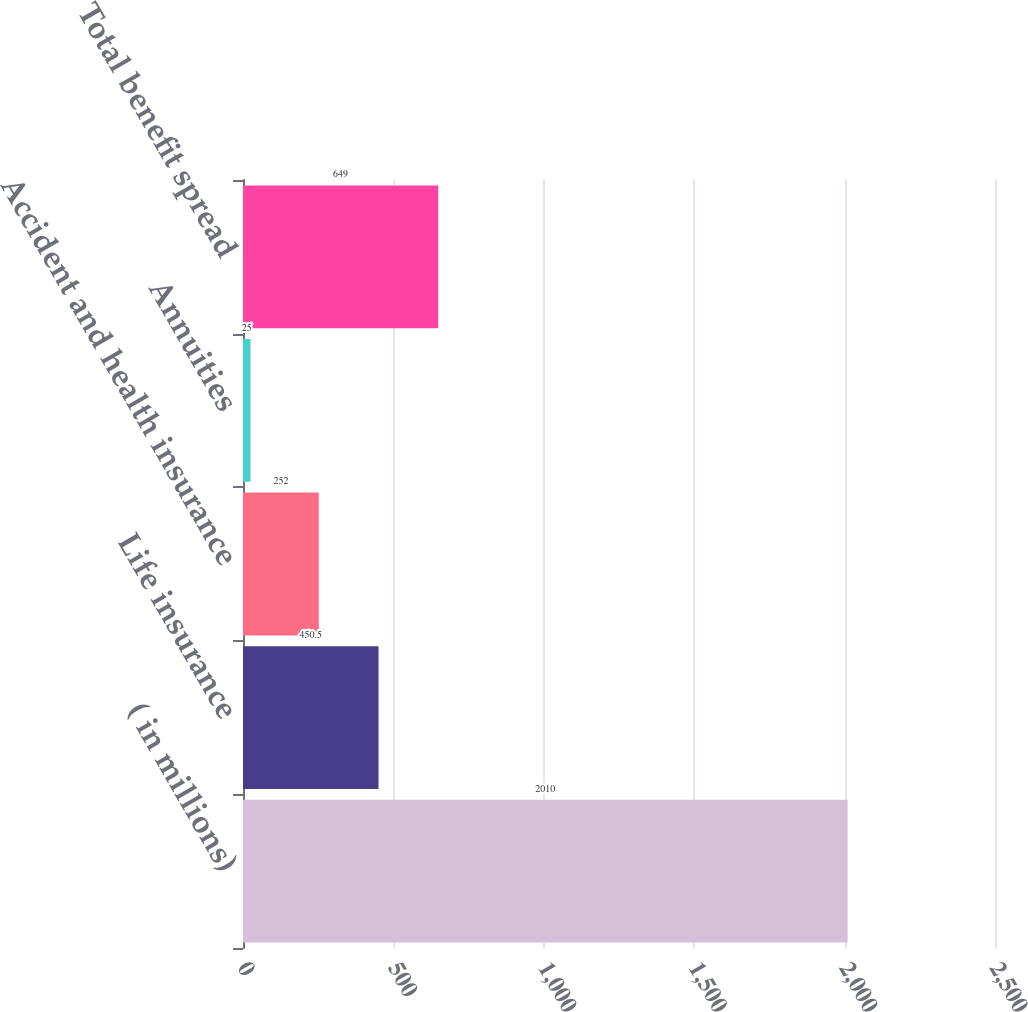Convert chart to OTSL. <chart><loc_0><loc_0><loc_500><loc_500><bar_chart><fcel>( in millions)<fcel>Life insurance<fcel>Accident and health insurance<fcel>Annuities<fcel>Total benefit spread<nl><fcel>2010<fcel>450.5<fcel>252<fcel>25<fcel>649<nl></chart> 